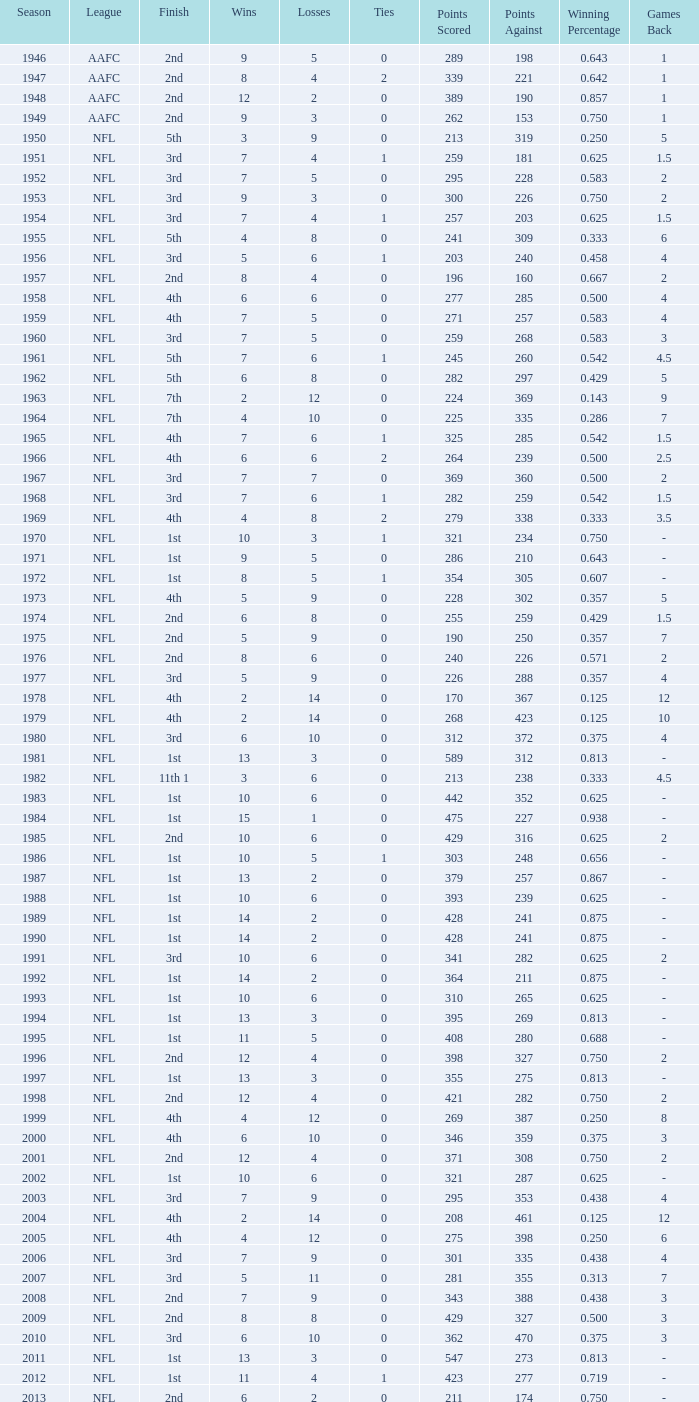What is the losses in the NFL in the 2011 season with less than 13 wins? None. 